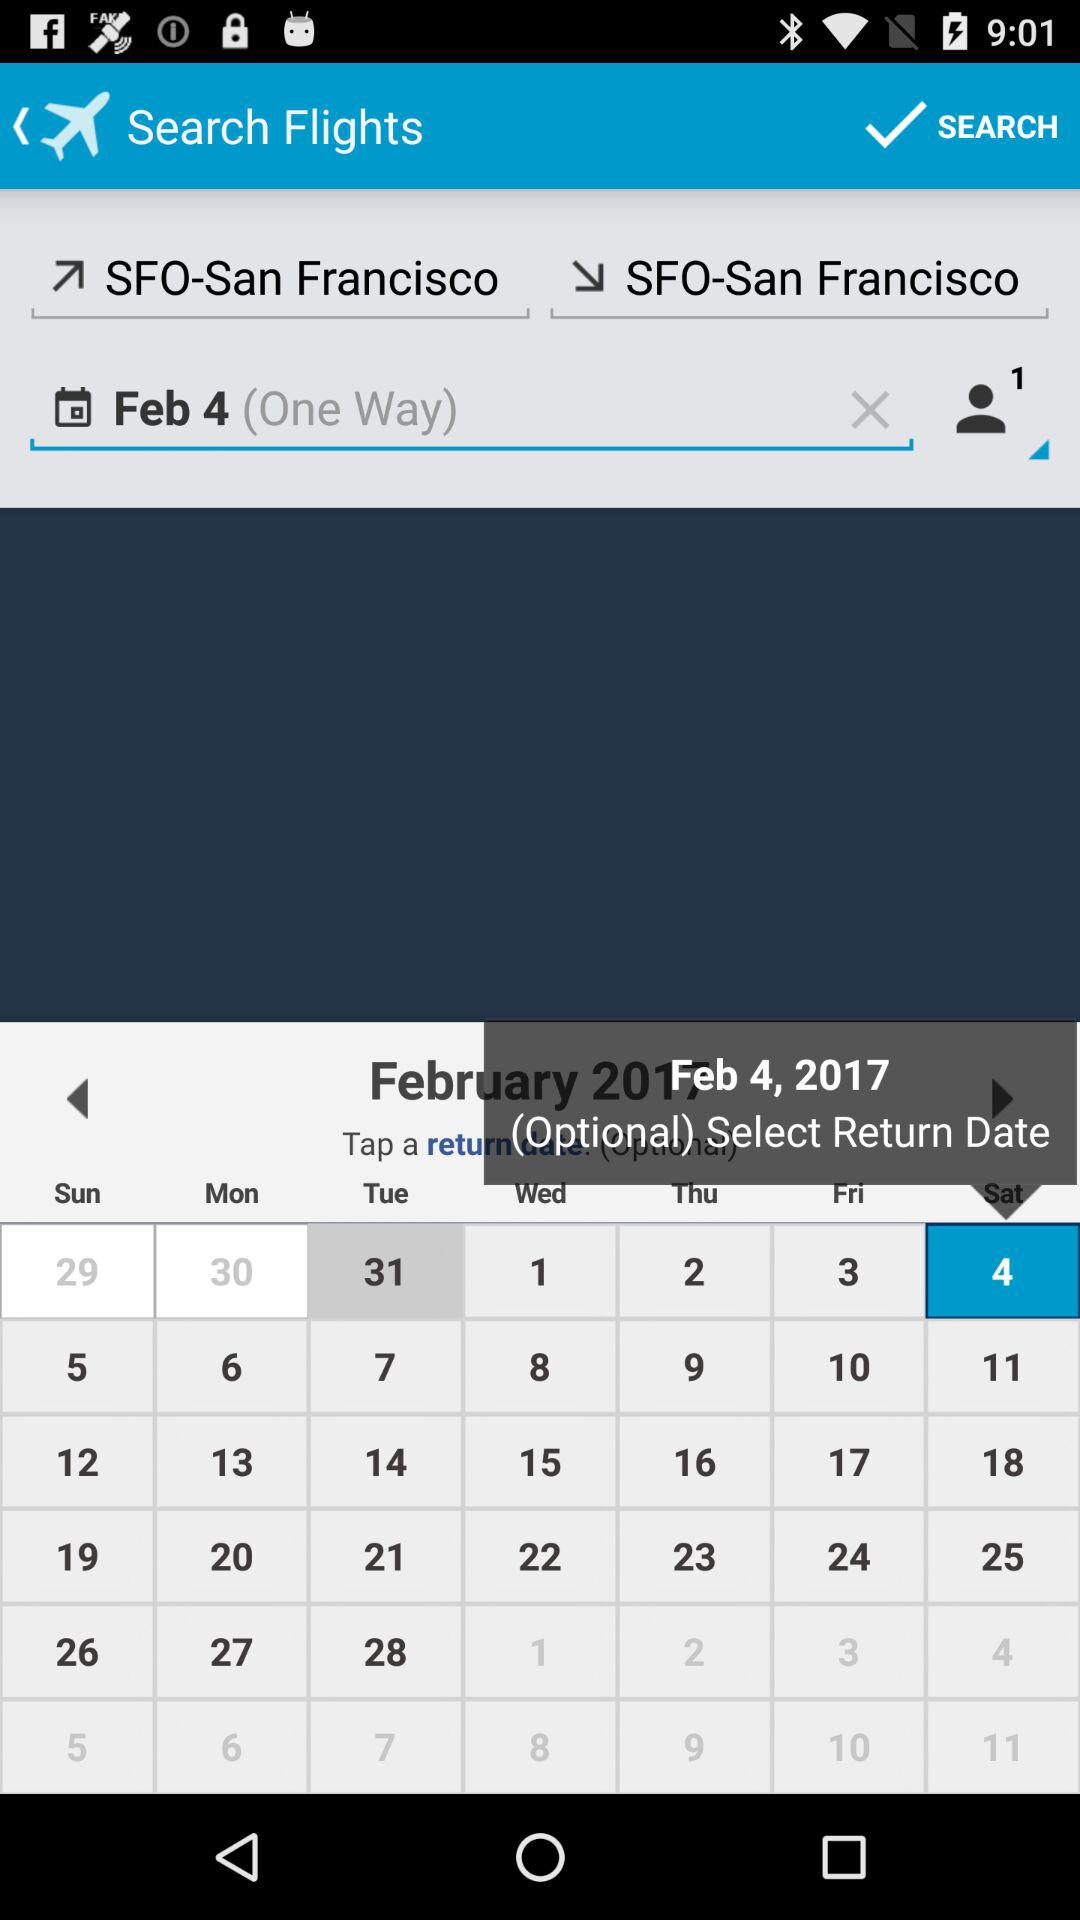The flight is booked for which way? The flight is booked for one way. 